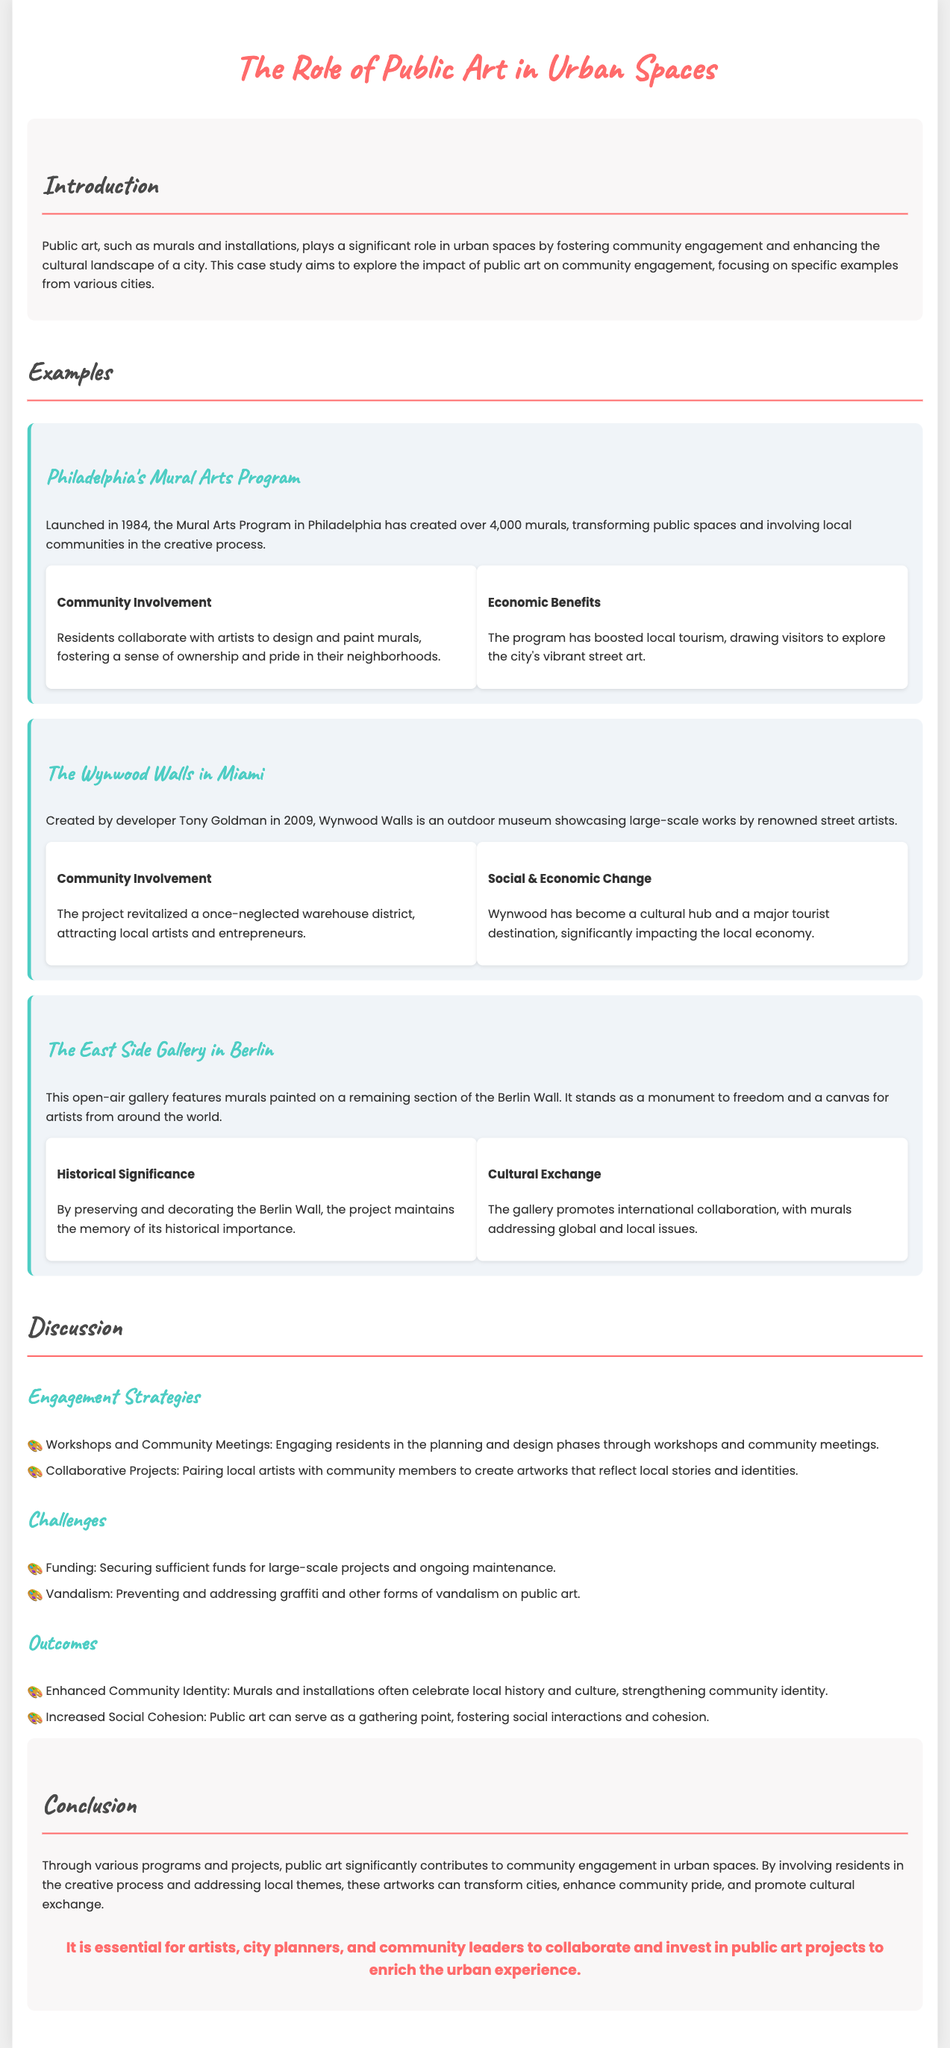What year was the Mural Arts Program in Philadelphia launched? The document states that the Mural Arts Program was launched in 1984.
Answer: 1984 How many murals has the Mural Arts Program created? According to the document, the Mural Arts Program has created over 4,000 murals.
Answer: Over 4,000 Who is the developer of Wynwood Walls in Miami? The document mentions that Wynwood Walls was created by developer Tony Goldman.
Answer: Tony Goldman What type of art is featured at the East Side Gallery in Berlin? The East Side Gallery features murals painted on a remaining section of the Berlin Wall.
Answer: Murals What is one of the engagement strategies mentioned in the discussion section? The document lists workshops and community meetings as engagement strategies to involve residents.
Answer: Workshops and Community Meetings What challenge does public art face according to the document? The document identifies funding as a challenge when it comes to public art projects.
Answer: Funding What outcome can public art lead to in communities? The document notes that public art can enhance community identity through its themes and designs.
Answer: Enhanced Community Identity What is the main purpose of the case study? The purpose of the case study is to explore the impact of public art on community engagement.
Answer: Explore the impact of public art on community engagement 